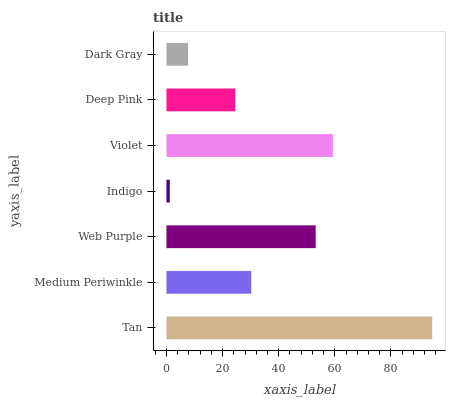Is Indigo the minimum?
Answer yes or no. Yes. Is Tan the maximum?
Answer yes or no. Yes. Is Medium Periwinkle the minimum?
Answer yes or no. No. Is Medium Periwinkle the maximum?
Answer yes or no. No. Is Tan greater than Medium Periwinkle?
Answer yes or no. Yes. Is Medium Periwinkle less than Tan?
Answer yes or no. Yes. Is Medium Periwinkle greater than Tan?
Answer yes or no. No. Is Tan less than Medium Periwinkle?
Answer yes or no. No. Is Medium Periwinkle the high median?
Answer yes or no. Yes. Is Medium Periwinkle the low median?
Answer yes or no. Yes. Is Deep Pink the high median?
Answer yes or no. No. Is Web Purple the low median?
Answer yes or no. No. 